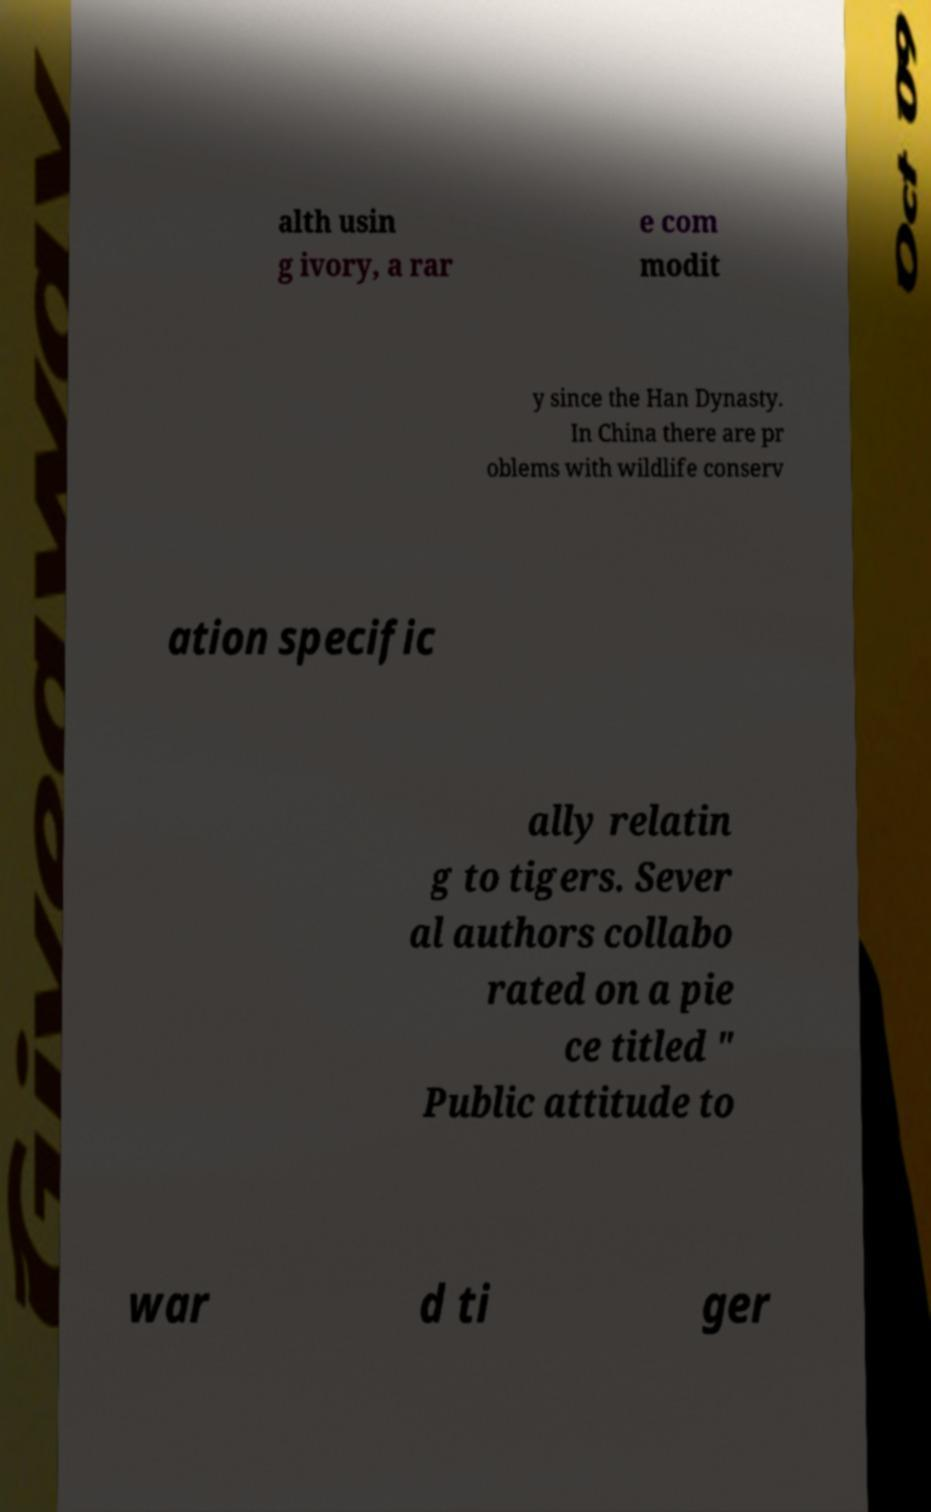Please read and relay the text visible in this image. What does it say? alth usin g ivory, a rar e com modit y since the Han Dynasty. In China there are pr oblems with wildlife conserv ation specific ally relatin g to tigers. Sever al authors collabo rated on a pie ce titled " Public attitude to war d ti ger 